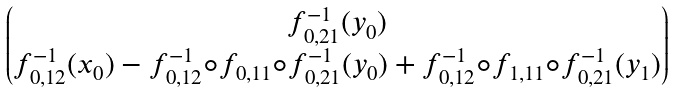<formula> <loc_0><loc_0><loc_500><loc_500>\begin{pmatrix} f ^ { - 1 } _ { 0 , 2 1 } ( y _ { 0 } ) \\ f ^ { - 1 } _ { 0 , 1 2 } ( x _ { 0 } ) - f ^ { - 1 } _ { 0 , 1 2 } \circ f _ { 0 , 1 1 } \circ f ^ { - 1 } _ { 0 , 2 1 } ( y _ { 0 } ) + f ^ { - 1 } _ { 0 , 1 2 } \circ f _ { 1 , 1 1 } \circ f ^ { - 1 } _ { 0 , 2 1 } ( y _ { 1 } ) \end{pmatrix}</formula> 